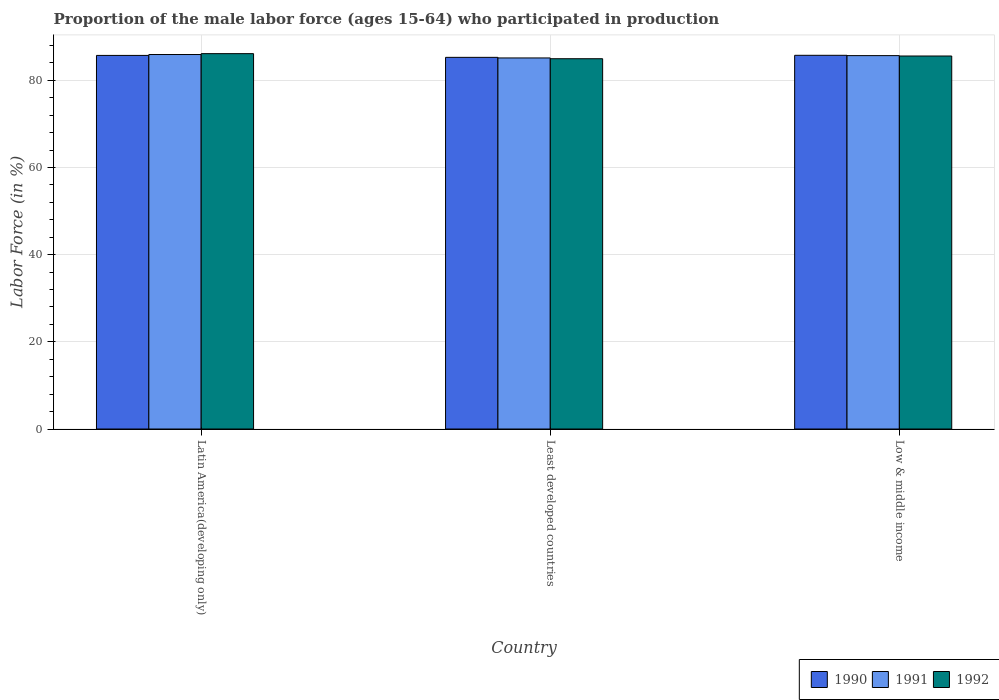Are the number of bars on each tick of the X-axis equal?
Provide a succinct answer. Yes. What is the label of the 3rd group of bars from the left?
Give a very brief answer. Low & middle income. What is the proportion of the male labor force who participated in production in 1992 in Latin America(developing only)?
Your response must be concise. 86.12. Across all countries, what is the maximum proportion of the male labor force who participated in production in 1990?
Offer a very short reply. 85.74. Across all countries, what is the minimum proportion of the male labor force who participated in production in 1990?
Give a very brief answer. 85.27. In which country was the proportion of the male labor force who participated in production in 1992 minimum?
Make the answer very short. Least developed countries. What is the total proportion of the male labor force who participated in production in 1991 in the graph?
Provide a short and direct response. 256.73. What is the difference between the proportion of the male labor force who participated in production in 1990 in Least developed countries and that in Low & middle income?
Keep it short and to the point. -0.47. What is the difference between the proportion of the male labor force who participated in production in 1990 in Latin America(developing only) and the proportion of the male labor force who participated in production in 1992 in Least developed countries?
Offer a very short reply. 0.76. What is the average proportion of the male labor force who participated in production in 1991 per country?
Your answer should be very brief. 85.58. What is the difference between the proportion of the male labor force who participated in production of/in 1991 and proportion of the male labor force who participated in production of/in 1992 in Low & middle income?
Your response must be concise. 0.09. What is the ratio of the proportion of the male labor force who participated in production in 1991 in Least developed countries to that in Low & middle income?
Your response must be concise. 0.99. Is the difference between the proportion of the male labor force who participated in production in 1991 in Latin America(developing only) and Least developed countries greater than the difference between the proportion of the male labor force who participated in production in 1992 in Latin America(developing only) and Least developed countries?
Give a very brief answer. No. What is the difference between the highest and the second highest proportion of the male labor force who participated in production in 1990?
Offer a terse response. -0.02. What is the difference between the highest and the lowest proportion of the male labor force who participated in production in 1991?
Make the answer very short. 0.79. What does the 2nd bar from the left in Latin America(developing only) represents?
Keep it short and to the point. 1991. What does the 3rd bar from the right in Latin America(developing only) represents?
Provide a short and direct response. 1990. Is it the case that in every country, the sum of the proportion of the male labor force who participated in production in 1991 and proportion of the male labor force who participated in production in 1992 is greater than the proportion of the male labor force who participated in production in 1990?
Ensure brevity in your answer.  Yes. What is the difference between two consecutive major ticks on the Y-axis?
Provide a short and direct response. 20. Does the graph contain grids?
Your answer should be compact. Yes. How many legend labels are there?
Your answer should be very brief. 3. How are the legend labels stacked?
Offer a terse response. Horizontal. What is the title of the graph?
Provide a succinct answer. Proportion of the male labor force (ages 15-64) who participated in production. What is the label or title of the Y-axis?
Your answer should be compact. Labor Force (in %). What is the Labor Force (in %) in 1990 in Latin America(developing only)?
Your answer should be very brief. 85.72. What is the Labor Force (in %) of 1991 in Latin America(developing only)?
Your response must be concise. 85.92. What is the Labor Force (in %) in 1992 in Latin America(developing only)?
Provide a succinct answer. 86.12. What is the Labor Force (in %) in 1990 in Least developed countries?
Ensure brevity in your answer.  85.27. What is the Labor Force (in %) in 1991 in Least developed countries?
Provide a short and direct response. 85.13. What is the Labor Force (in %) in 1992 in Least developed countries?
Your response must be concise. 84.96. What is the Labor Force (in %) of 1990 in Low & middle income?
Make the answer very short. 85.74. What is the Labor Force (in %) of 1991 in Low & middle income?
Your answer should be compact. 85.67. What is the Labor Force (in %) of 1992 in Low & middle income?
Give a very brief answer. 85.58. Across all countries, what is the maximum Labor Force (in %) in 1990?
Your answer should be very brief. 85.74. Across all countries, what is the maximum Labor Force (in %) of 1991?
Offer a very short reply. 85.92. Across all countries, what is the maximum Labor Force (in %) of 1992?
Your response must be concise. 86.12. Across all countries, what is the minimum Labor Force (in %) in 1990?
Provide a short and direct response. 85.27. Across all countries, what is the minimum Labor Force (in %) of 1991?
Your answer should be very brief. 85.13. Across all countries, what is the minimum Labor Force (in %) of 1992?
Your response must be concise. 84.96. What is the total Labor Force (in %) of 1990 in the graph?
Make the answer very short. 256.73. What is the total Labor Force (in %) in 1991 in the graph?
Your response must be concise. 256.73. What is the total Labor Force (in %) in 1992 in the graph?
Ensure brevity in your answer.  256.66. What is the difference between the Labor Force (in %) in 1990 in Latin America(developing only) and that in Least developed countries?
Your answer should be compact. 0.44. What is the difference between the Labor Force (in %) of 1991 in Latin America(developing only) and that in Least developed countries?
Make the answer very short. 0.79. What is the difference between the Labor Force (in %) in 1992 in Latin America(developing only) and that in Least developed countries?
Your answer should be very brief. 1.17. What is the difference between the Labor Force (in %) in 1990 in Latin America(developing only) and that in Low & middle income?
Keep it short and to the point. -0.02. What is the difference between the Labor Force (in %) in 1991 in Latin America(developing only) and that in Low & middle income?
Your answer should be very brief. 0.25. What is the difference between the Labor Force (in %) in 1992 in Latin America(developing only) and that in Low & middle income?
Provide a succinct answer. 0.54. What is the difference between the Labor Force (in %) of 1990 in Least developed countries and that in Low & middle income?
Provide a succinct answer. -0.47. What is the difference between the Labor Force (in %) of 1991 in Least developed countries and that in Low & middle income?
Offer a very short reply. -0.54. What is the difference between the Labor Force (in %) in 1992 in Least developed countries and that in Low & middle income?
Give a very brief answer. -0.62. What is the difference between the Labor Force (in %) in 1990 in Latin America(developing only) and the Labor Force (in %) in 1991 in Least developed countries?
Give a very brief answer. 0.58. What is the difference between the Labor Force (in %) in 1990 in Latin America(developing only) and the Labor Force (in %) in 1992 in Least developed countries?
Make the answer very short. 0.76. What is the difference between the Labor Force (in %) in 1991 in Latin America(developing only) and the Labor Force (in %) in 1992 in Least developed countries?
Provide a short and direct response. 0.96. What is the difference between the Labor Force (in %) of 1990 in Latin America(developing only) and the Labor Force (in %) of 1991 in Low & middle income?
Make the answer very short. 0.05. What is the difference between the Labor Force (in %) in 1990 in Latin America(developing only) and the Labor Force (in %) in 1992 in Low & middle income?
Your answer should be compact. 0.14. What is the difference between the Labor Force (in %) in 1991 in Latin America(developing only) and the Labor Force (in %) in 1992 in Low & middle income?
Your response must be concise. 0.34. What is the difference between the Labor Force (in %) in 1990 in Least developed countries and the Labor Force (in %) in 1991 in Low & middle income?
Give a very brief answer. -0.4. What is the difference between the Labor Force (in %) in 1990 in Least developed countries and the Labor Force (in %) in 1992 in Low & middle income?
Your answer should be compact. -0.31. What is the difference between the Labor Force (in %) in 1991 in Least developed countries and the Labor Force (in %) in 1992 in Low & middle income?
Ensure brevity in your answer.  -0.45. What is the average Labor Force (in %) in 1990 per country?
Give a very brief answer. 85.58. What is the average Labor Force (in %) of 1991 per country?
Ensure brevity in your answer.  85.58. What is the average Labor Force (in %) of 1992 per country?
Ensure brevity in your answer.  85.55. What is the difference between the Labor Force (in %) in 1990 and Labor Force (in %) in 1991 in Latin America(developing only)?
Offer a very short reply. -0.2. What is the difference between the Labor Force (in %) of 1990 and Labor Force (in %) of 1992 in Latin America(developing only)?
Your response must be concise. -0.41. What is the difference between the Labor Force (in %) in 1991 and Labor Force (in %) in 1992 in Latin America(developing only)?
Keep it short and to the point. -0.2. What is the difference between the Labor Force (in %) of 1990 and Labor Force (in %) of 1991 in Least developed countries?
Keep it short and to the point. 0.14. What is the difference between the Labor Force (in %) in 1990 and Labor Force (in %) in 1992 in Least developed countries?
Offer a terse response. 0.32. What is the difference between the Labor Force (in %) of 1991 and Labor Force (in %) of 1992 in Least developed countries?
Give a very brief answer. 0.18. What is the difference between the Labor Force (in %) in 1990 and Labor Force (in %) in 1991 in Low & middle income?
Provide a short and direct response. 0.07. What is the difference between the Labor Force (in %) in 1990 and Labor Force (in %) in 1992 in Low & middle income?
Make the answer very short. 0.16. What is the difference between the Labor Force (in %) in 1991 and Labor Force (in %) in 1992 in Low & middle income?
Provide a short and direct response. 0.09. What is the ratio of the Labor Force (in %) in 1991 in Latin America(developing only) to that in Least developed countries?
Your response must be concise. 1.01. What is the ratio of the Labor Force (in %) in 1992 in Latin America(developing only) to that in Least developed countries?
Your answer should be compact. 1.01. What is the ratio of the Labor Force (in %) in 1992 in Latin America(developing only) to that in Low & middle income?
Give a very brief answer. 1.01. What is the ratio of the Labor Force (in %) in 1991 in Least developed countries to that in Low & middle income?
Make the answer very short. 0.99. What is the difference between the highest and the second highest Labor Force (in %) of 1990?
Your answer should be compact. 0.02. What is the difference between the highest and the second highest Labor Force (in %) in 1991?
Keep it short and to the point. 0.25. What is the difference between the highest and the second highest Labor Force (in %) in 1992?
Provide a succinct answer. 0.54. What is the difference between the highest and the lowest Labor Force (in %) of 1990?
Your answer should be very brief. 0.47. What is the difference between the highest and the lowest Labor Force (in %) of 1991?
Ensure brevity in your answer.  0.79. What is the difference between the highest and the lowest Labor Force (in %) in 1992?
Keep it short and to the point. 1.17. 